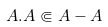Convert formula to latex. <formula><loc_0><loc_0><loc_500><loc_500>A . A \Subset A - A</formula> 